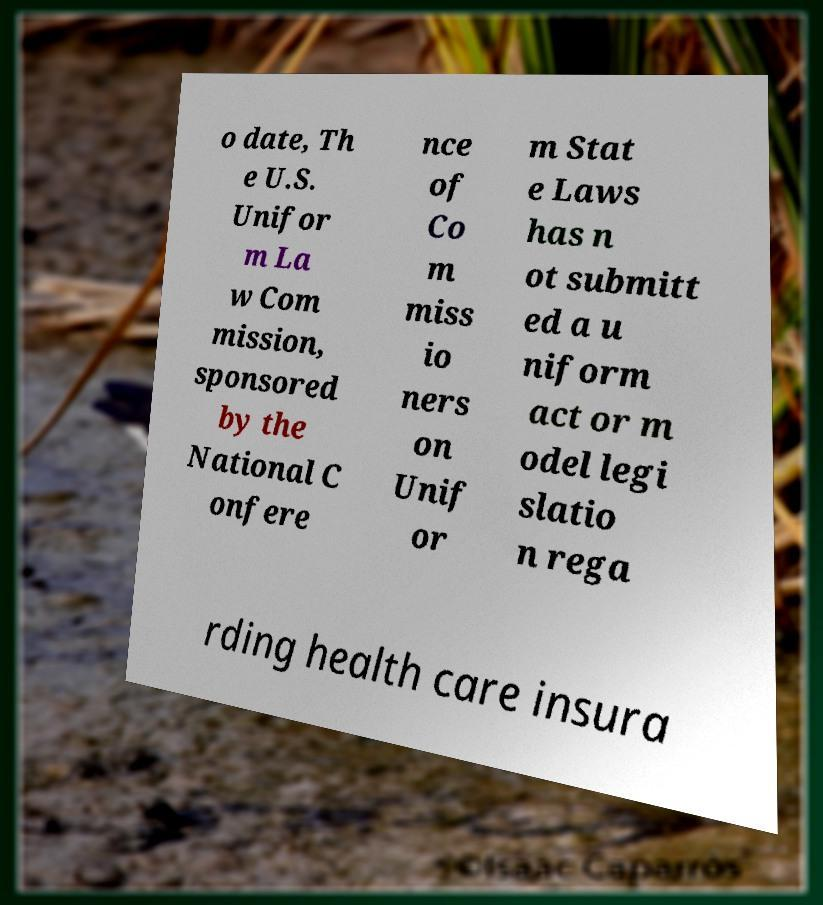Please read and relay the text visible in this image. What does it say? o date, Th e U.S. Unifor m La w Com mission, sponsored by the National C onfere nce of Co m miss io ners on Unif or m Stat e Laws has n ot submitt ed a u niform act or m odel legi slatio n rega rding health care insura 